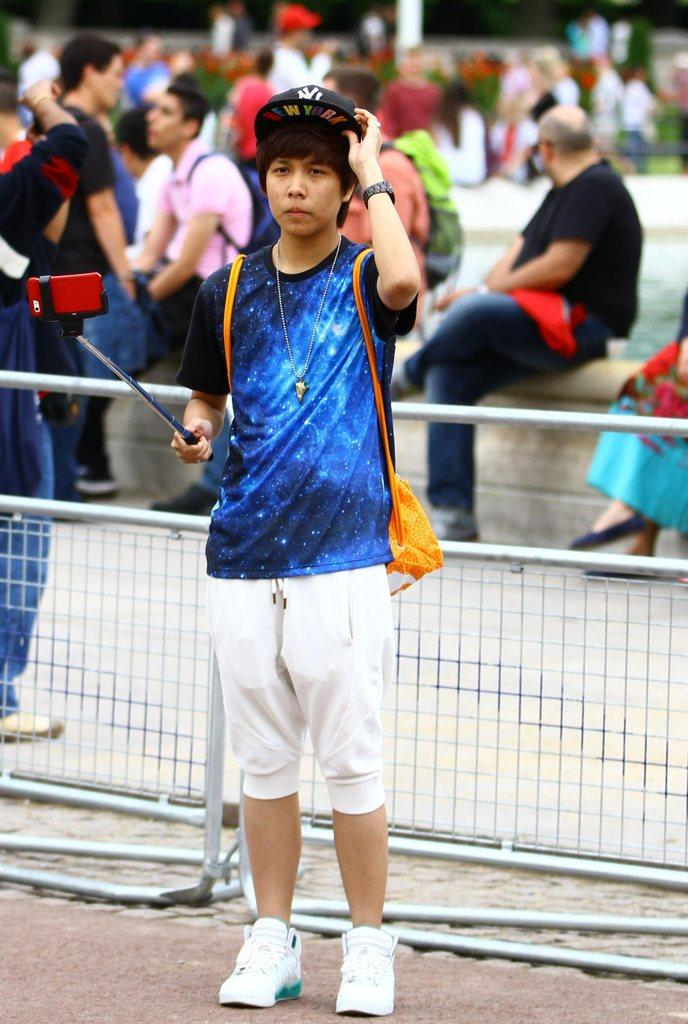What is the main subject of the image? The main subject of the image is a man. What is the man wearing? The man is wearing a t-shirt, trousers, shoes, and a cap. What is the man holding in the image? The man is holding a stick. What can be seen in the background of the image? There are people sitting and standing in the background, as well as a fence. Can you tell me what type of request the man is making in the image? There is no indication in the image that the man is making any request. What type of needle is the man using in the image? There is no needle present in the image. 